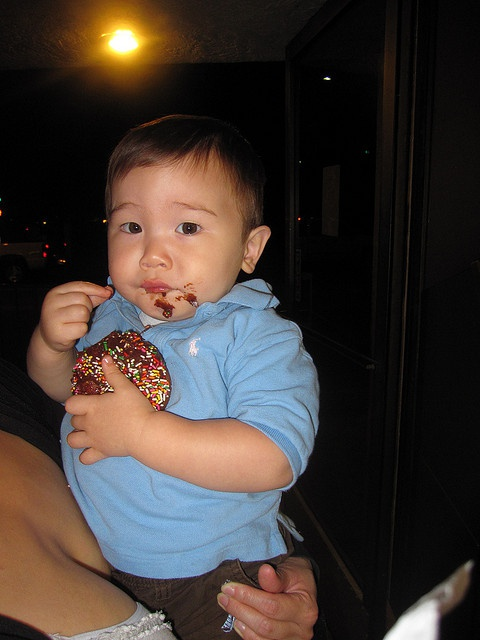Describe the objects in this image and their specific colors. I can see people in black, lightblue, gray, and tan tones, people in black, brown, and maroon tones, and donut in black, maroon, white, and olive tones in this image. 